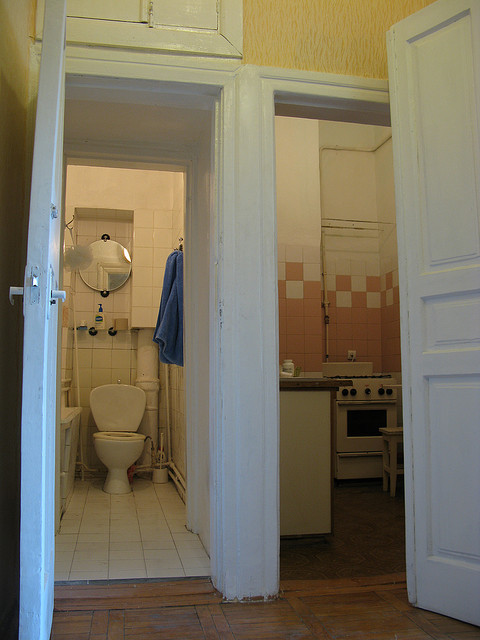How would you describe the overall condition and style of this interior? The interior shows a rustic and vintage style with moderate wear. Elements such as the worn floor, traditional ceramic tiles, and classic white doors contribute to a lived-in, nostalgic atmosphere. 